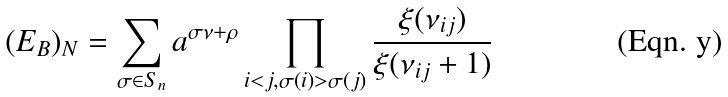Convert formula to latex. <formula><loc_0><loc_0><loc_500><loc_500>( E _ { B } ) _ { N } = \sum _ { \sigma \in S _ { n } } a ^ { \sigma \nu + \rho } \prod _ { i < j , \sigma ( i ) > \sigma ( j ) } \frac { \xi ( \nu _ { i j } ) } { \xi ( \nu _ { i j } + 1 ) }</formula> 